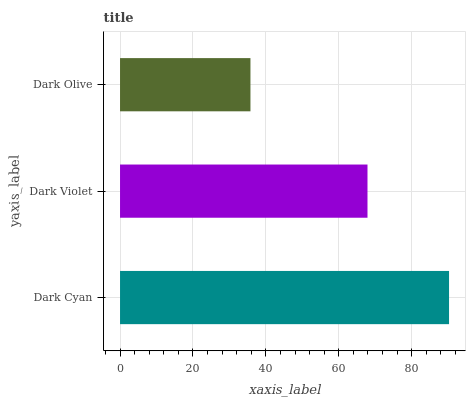Is Dark Olive the minimum?
Answer yes or no. Yes. Is Dark Cyan the maximum?
Answer yes or no. Yes. Is Dark Violet the minimum?
Answer yes or no. No. Is Dark Violet the maximum?
Answer yes or no. No. Is Dark Cyan greater than Dark Violet?
Answer yes or no. Yes. Is Dark Violet less than Dark Cyan?
Answer yes or no. Yes. Is Dark Violet greater than Dark Cyan?
Answer yes or no. No. Is Dark Cyan less than Dark Violet?
Answer yes or no. No. Is Dark Violet the high median?
Answer yes or no. Yes. Is Dark Violet the low median?
Answer yes or no. Yes. Is Dark Olive the high median?
Answer yes or no. No. Is Dark Olive the low median?
Answer yes or no. No. 